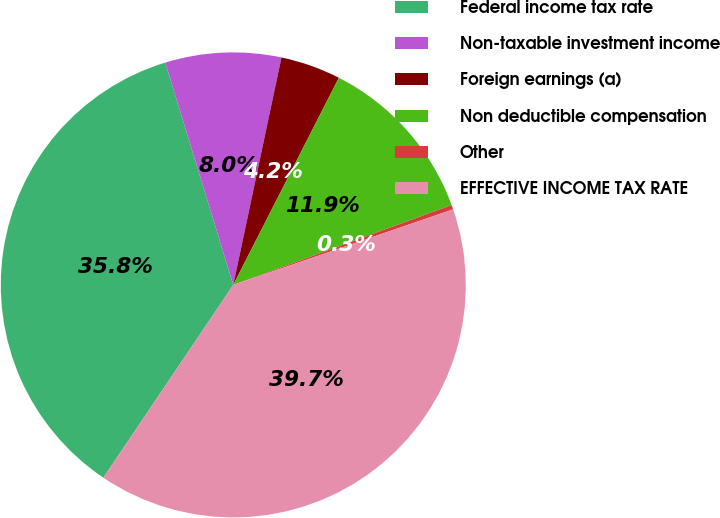Convert chart to OTSL. <chart><loc_0><loc_0><loc_500><loc_500><pie_chart><fcel>Federal income tax rate<fcel>Non-taxable investment income<fcel>Foreign earnings (a)<fcel>Non deductible compensation<fcel>Other<fcel>EFFECTIVE INCOME TAX RATE<nl><fcel>35.84%<fcel>8.05%<fcel>4.18%<fcel>11.92%<fcel>0.31%<fcel>39.71%<nl></chart> 